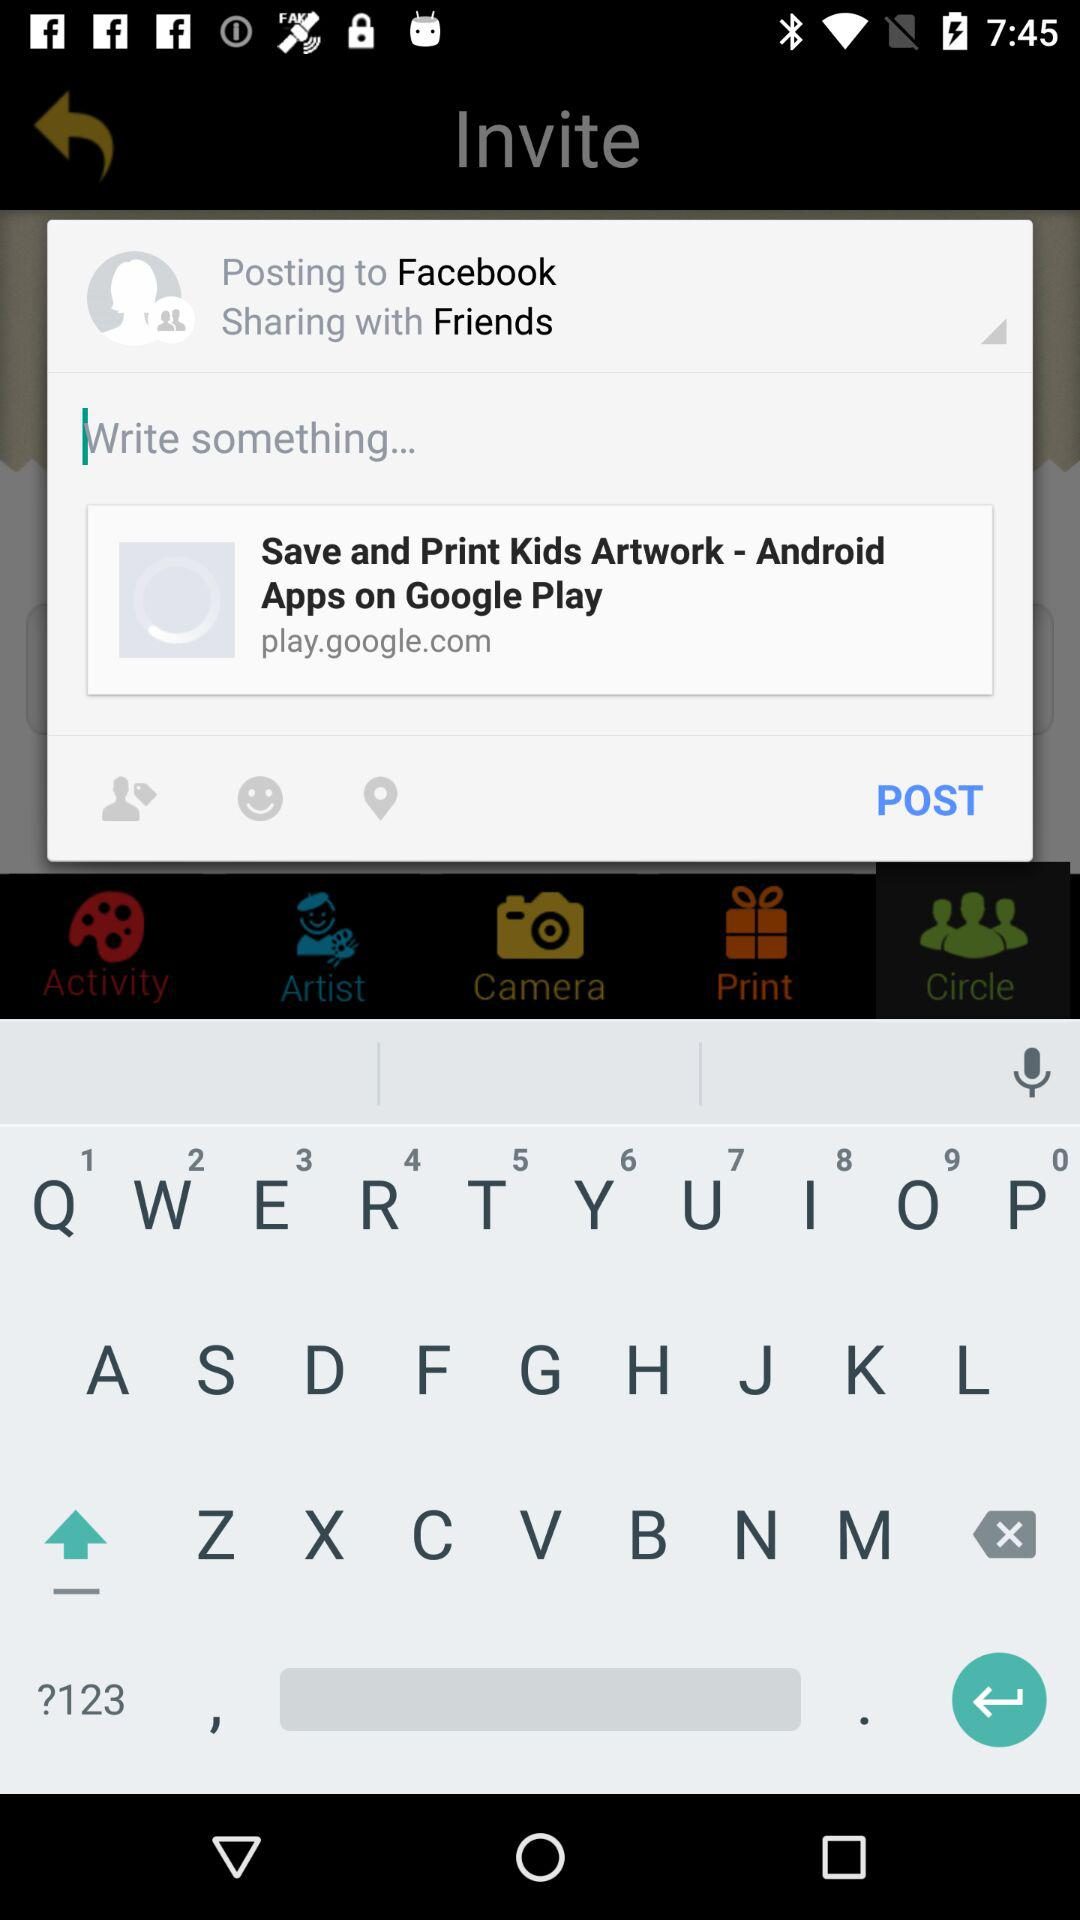What is the selected date? The selected date is Monday, May 8, 2017. 